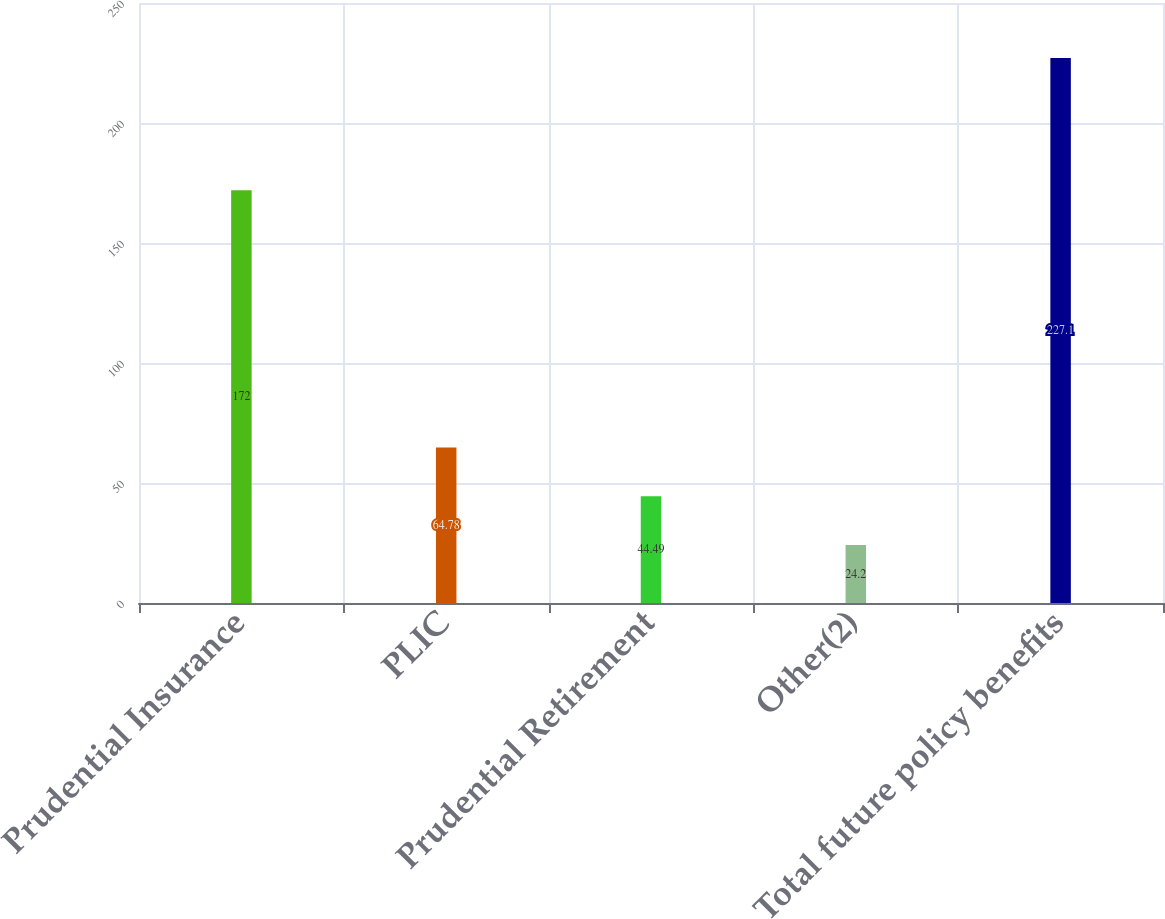Convert chart to OTSL. <chart><loc_0><loc_0><loc_500><loc_500><bar_chart><fcel>Prudential Insurance<fcel>PLIC<fcel>Prudential Retirement<fcel>Other(2)<fcel>Total future policy benefits<nl><fcel>172<fcel>64.78<fcel>44.49<fcel>24.2<fcel>227.1<nl></chart> 